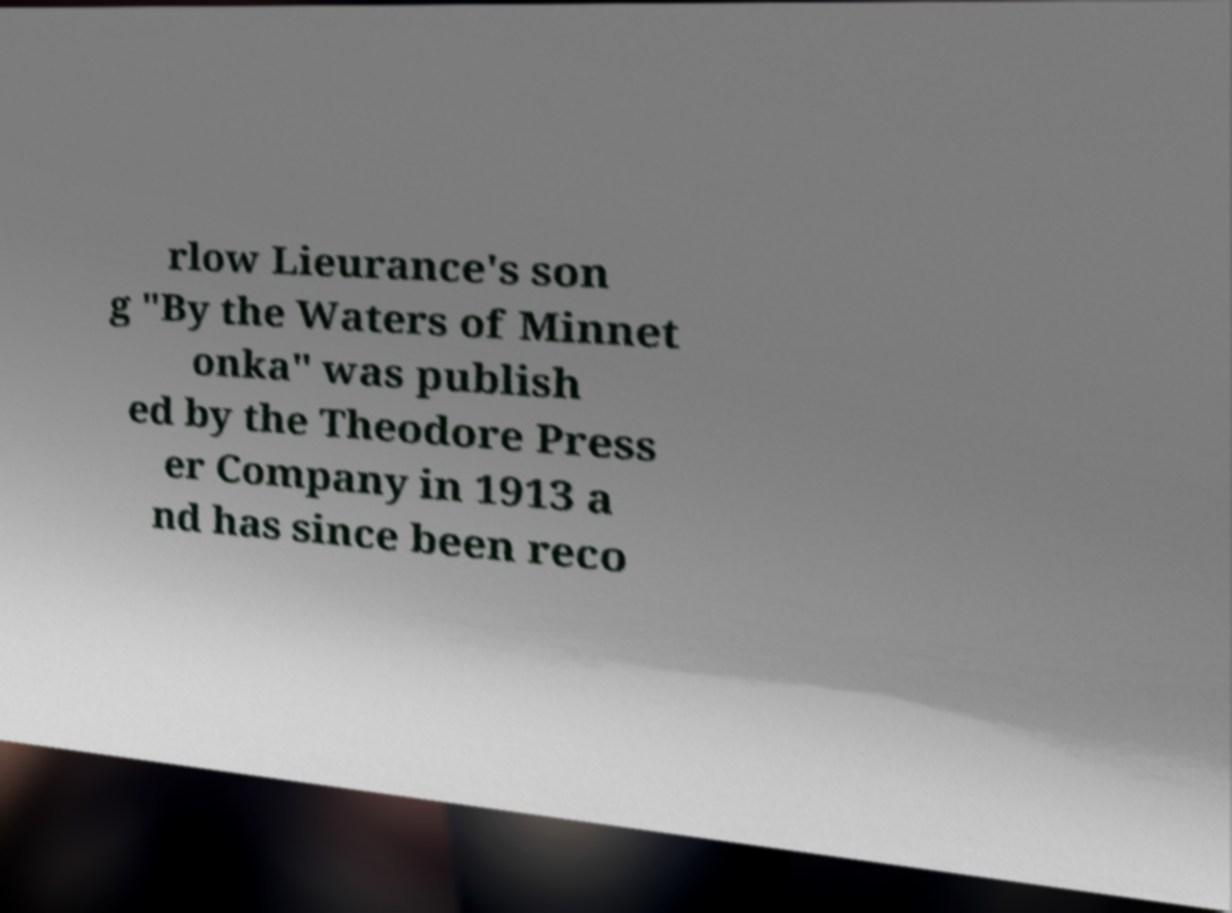There's text embedded in this image that I need extracted. Can you transcribe it verbatim? rlow Lieurance's son g "By the Waters of Minnet onka" was publish ed by the Theodore Press er Company in 1913 a nd has since been reco 